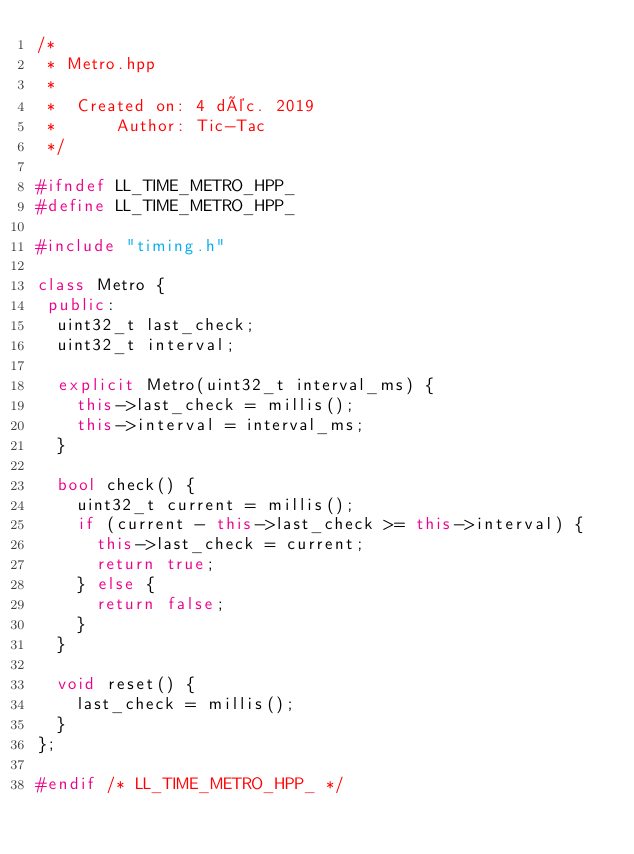<code> <loc_0><loc_0><loc_500><loc_500><_C++_>/*
 * Metro.hpp
 *
 *  Created on: 4 déc. 2019
 *      Author: Tic-Tac
 */

#ifndef LL_TIME_METRO_HPP_
#define LL_TIME_METRO_HPP_

#include "timing.h"

class Metro {
 public:
  uint32_t last_check;
  uint32_t interval;

  explicit Metro(uint32_t interval_ms) {
    this->last_check = millis();
    this->interval = interval_ms;
  }

  bool check() {
    uint32_t current = millis();
    if (current - this->last_check >= this->interval) {
      this->last_check = current;
      return true;
    } else {
      return false;
    }
  }

  void reset() {
    last_check = millis();
  }
};

#endif /* LL_TIME_METRO_HPP_ */
</code> 